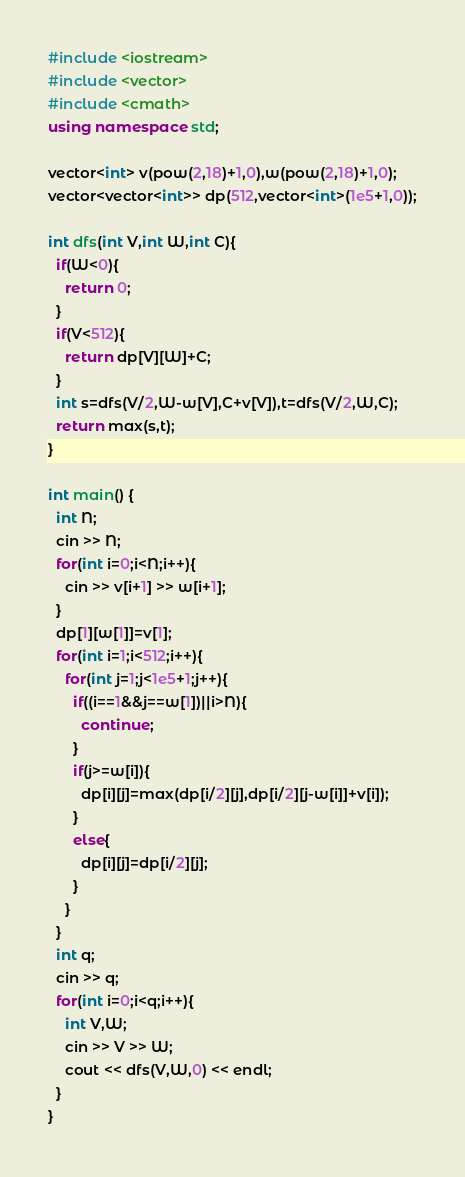Convert code to text. <code><loc_0><loc_0><loc_500><loc_500><_C++_>#include <iostream>
#include <vector>
#include <cmath>
using namespace std;

vector<int> v(pow(2,18)+1,0),w(pow(2,18)+1,0);
vector<vector<int>> dp(512,vector<int>(1e5+1,0));

int dfs(int V,int W,int C){
  if(W<0){
    return 0;
  }
  if(V<512){
    return dp[V][W]+C;
  }
  int s=dfs(V/2,W-w[V],C+v[V]),t=dfs(V/2,W,C);
  return max(s,t);
}

int main() {
  int N;
  cin >> N;
  for(int i=0;i<N;i++){
    cin >> v[i+1] >> w[i+1];
  }
  dp[1][w[1]]=v[1];
  for(int i=1;i<512;i++){
    for(int j=1;j<1e5+1;j++){
      if((i==1&&j==w[1])||i>N){
        continue;
      }
      if(j>=w[i]){
        dp[i][j]=max(dp[i/2][j],dp[i/2][j-w[i]]+v[i]);
      }
      else{
        dp[i][j]=dp[i/2][j];
      }
    }
  }
  int q;
  cin >> q;
  for(int i=0;i<q;i++){
    int V,W;
    cin >> V >> W;
    cout << dfs(V,W,0) << endl;
  }
}
</code> 